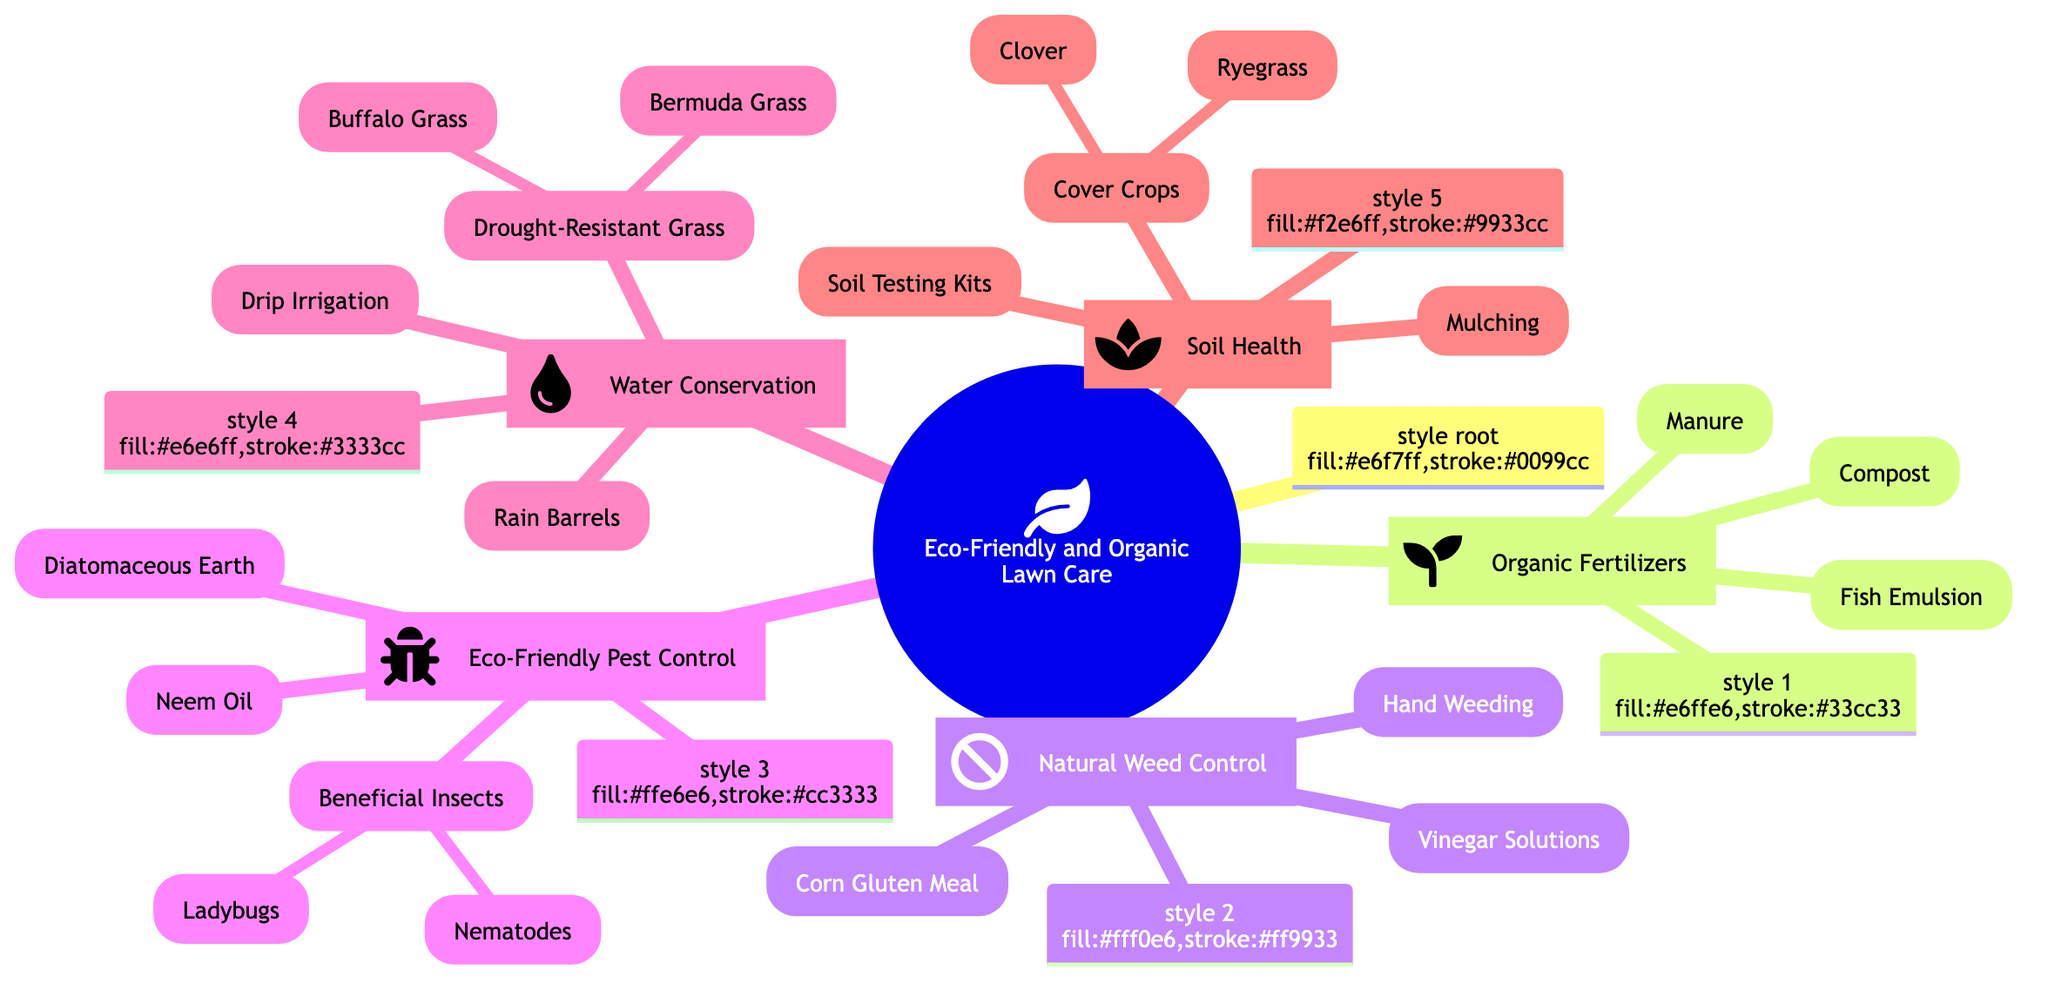What are the three main categories of eco-friendly lawn care options? The diagram has three main categories labeled as Organic Fertilizers, Natural Weed Control, and Eco-Friendly Pest Control, which are the primary divisions under Eco-Friendly and Organic Lawn Care Options.
Answer: Organic Fertilizers, Natural Weed Control, Eco-Friendly Pest Control How many types of organic fertilizers are listed? Under the Organic Fertilizers category, there are three sub-nodes: Compost, Manure, and Fish Emulsion, indicating that there are a total of three types.
Answer: 3 What natural weed control option prevents weed seeds from germinating? In the Natural Weed Control section, Corn Gluten Meal is mentioned specifically as a solution that prevents weed seeds from germinating, making it the correct answer.
Answer: Corn Gluten Meal Which pest control method uses insects to manage pests? Beneficial Insects is a sub-category under Eco-Friendly Pest Control and contains Ladybugs and Nematodes, both of which are used to manage pest problems. This indicates that beneficial insects are the method in question.
Answer: Beneficial Insects What is the main purpose of using rain barrels? The Rain Barrels node in the Water Conservation category states that their purpose is to collect rainwater for irrigation purposes. This succinctly identifies the role of rain barrels in eco-friendly lawn care.
Answer: Collect rainwater for irrigation How does mulching contribute to soil health? The Mulching node under Soil Health indicates that it retains moisture and suppresses weeds, showing its benefits for maintaining soil health effectively by providing two key points.
Answer: Retains moisture, suppresses weeds What type of grass is described as heat and drought-tolerant? The diagram lists Buffalo Grass under the Drought-Resistant Grass category and specifically states that it is heat and drought-tolerant, making Buffalo Grass the correct answer.
Answer: Buffalo Grass Which organic fertilizer is described as rich in nutrients? The details provided under the Compost node indicate it is rich in nutrients and improves soil structure and water retention, therefore making Compost the answer.
Answer: Compost 